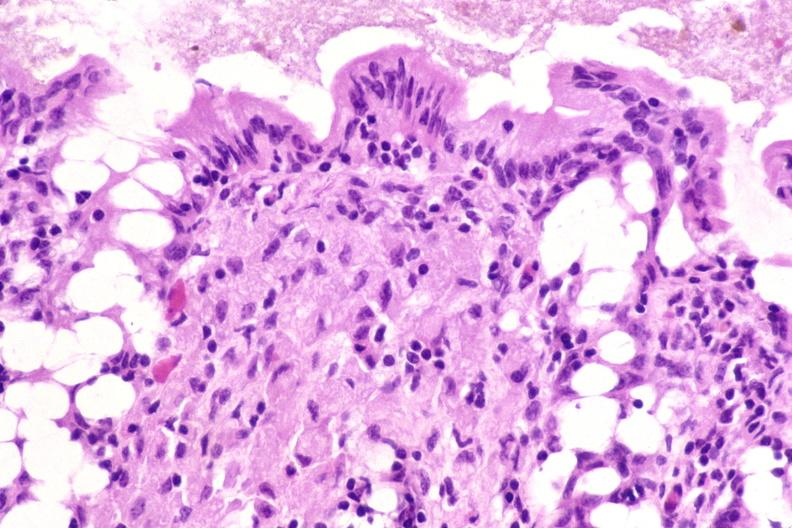do acid stain?
Answer the question using a single word or phrase. Yes 